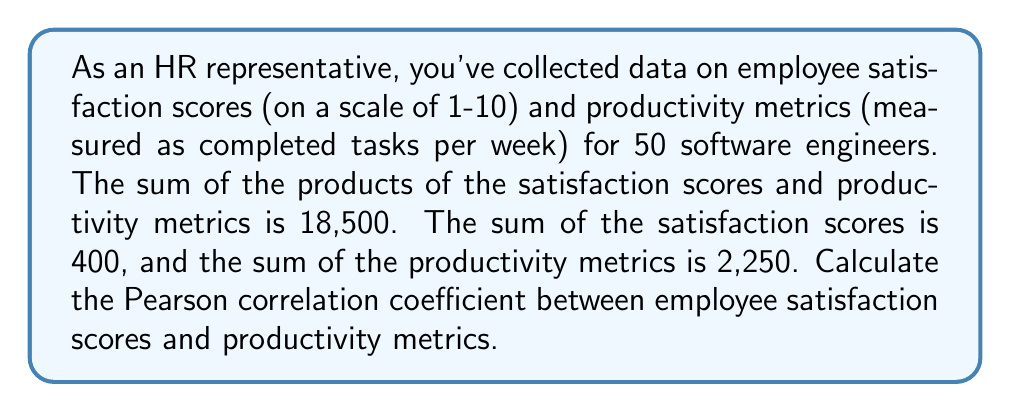Provide a solution to this math problem. To calculate the Pearson correlation coefficient, we'll use the formula:

$$ r = \frac{n\sum xy - (\sum x)(\sum y)}{\sqrt{[n\sum x^2 - (\sum x)^2][n\sum y^2 - (\sum y)^2]}} $$

Where:
$n$ = number of pairs of scores
$x$ = employee satisfaction scores
$y$ = productivity metrics

Given:
$n = 50$
$\sum xy = 18,500$
$\sum x = 400$
$\sum y = 2,250$

We need to calculate $\sum x^2$ and $\sum y^2$:

1. Calculate $\overline{x}$ and $\overline{y}$:
   $\overline{x} = \frac{\sum x}{n} = \frac{400}{50} = 8$
   $\overline{y} = \frac{\sum y}{n} = \frac{2,250}{50} = 45$

2. Use the formula: $\sum x^2 = n(\overline{x}^2 + s_x^2)$, where $s_x^2$ is the variance of x.
   Similarly for $\sum y^2$.

3. Estimate $s_x^2$ and $s_y^2$ (assuming a moderate spread):
   $s_x^2 \approx 4$ (variance of satisfaction scores)
   $s_y^2 \approx 100$ (variance of productivity metrics)

4. Calculate $\sum x^2$ and $\sum y^2$:
   $\sum x^2 = 50(8^2 + 4) = 50(68) = 3,400$
   $\sum y^2 = 50(45^2 + 100) = 50(2,125) = 106,250$

Now we can apply the correlation coefficient formula:

$$ r = \frac{50(18,500) - (400)(2,250)}{\sqrt{[50(3,400) - 400^2][50(106,250) - 2,250^2]}} $$

$$ r = \frac{925,000 - 900,000}{\sqrt{(170,000 - 160,000)(5,312,500 - 5,062,500)}} $$

$$ r = \frac{25,000}{\sqrt{(10,000)(250,000)}} = \frac{25,000}{50,000} = 0.5 $$
Answer: The Pearson correlation coefficient between employee satisfaction scores and productivity metrics is 0.5, indicating a moderate positive correlation. 